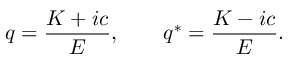Convert formula to latex. <formula><loc_0><loc_0><loc_500><loc_500>q = \frac { K + i c } { E } , q ^ { * } = \frac { K - i c } { E } .</formula> 